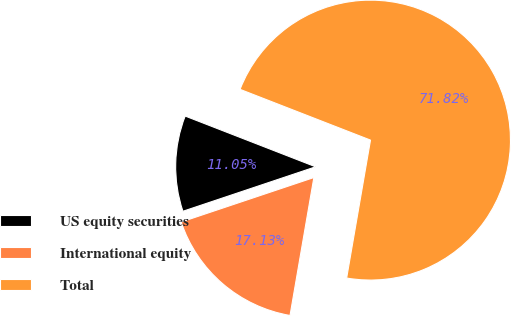Convert chart. <chart><loc_0><loc_0><loc_500><loc_500><pie_chart><fcel>US equity securities<fcel>International equity<fcel>Total<nl><fcel>11.05%<fcel>17.13%<fcel>71.82%<nl></chart> 